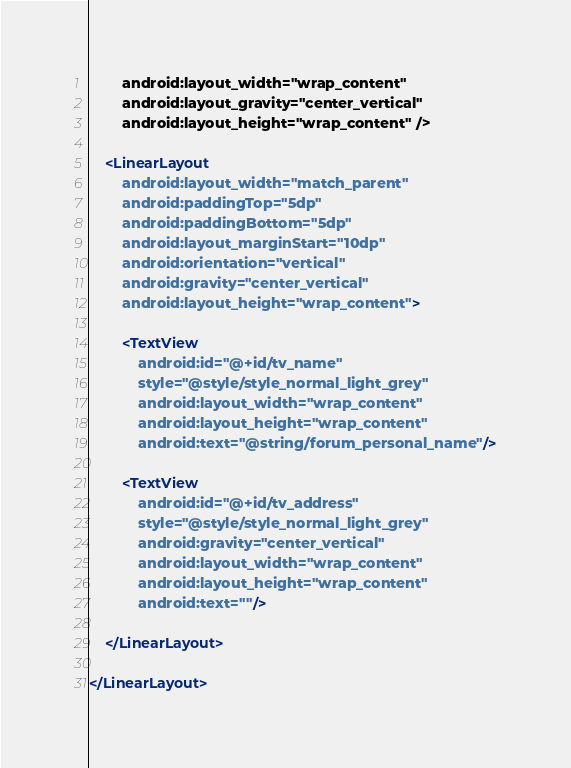<code> <loc_0><loc_0><loc_500><loc_500><_XML_>        android:layout_width="wrap_content"
        android:layout_gravity="center_vertical"
        android:layout_height="wrap_content" />

    <LinearLayout
        android:layout_width="match_parent"
        android:paddingTop="5dp"
        android:paddingBottom="5dp"
        android:layout_marginStart="10dp"
        android:orientation="vertical"
        android:gravity="center_vertical"
        android:layout_height="wrap_content">

        <TextView
            android:id="@+id/tv_name"
            style="@style/style_normal_light_grey"
            android:layout_width="wrap_content"
            android:layout_height="wrap_content"
            android:text="@string/forum_personal_name"/>

        <TextView
            android:id="@+id/tv_address"
            style="@style/style_normal_light_grey"
            android:gravity="center_vertical"
            android:layout_width="wrap_content"
            android:layout_height="wrap_content"
            android:text=""/>

    </LinearLayout>

</LinearLayout>
</code> 